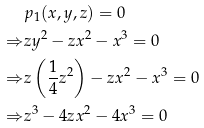Convert formula to latex. <formula><loc_0><loc_0><loc_500><loc_500>& p _ { 1 } ( x , y , z ) = 0 \\ \Rightarrow & z y ^ { 2 } - z x ^ { 2 } - x ^ { 3 } = 0 \\ \Rightarrow & z \left ( \frac { 1 } { 4 } z ^ { 2 } \right ) - z x ^ { 2 } - x ^ { 3 } = 0 \\ \Rightarrow & z ^ { 3 } - 4 z x ^ { 2 } - 4 x ^ { 3 } = 0</formula> 